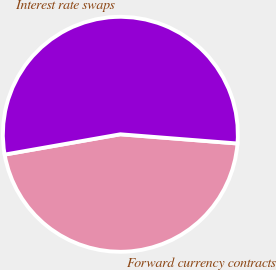Convert chart to OTSL. <chart><loc_0><loc_0><loc_500><loc_500><pie_chart><fcel>Forward currency contracts<fcel>Interest rate swaps<nl><fcel>45.99%<fcel>54.01%<nl></chart> 